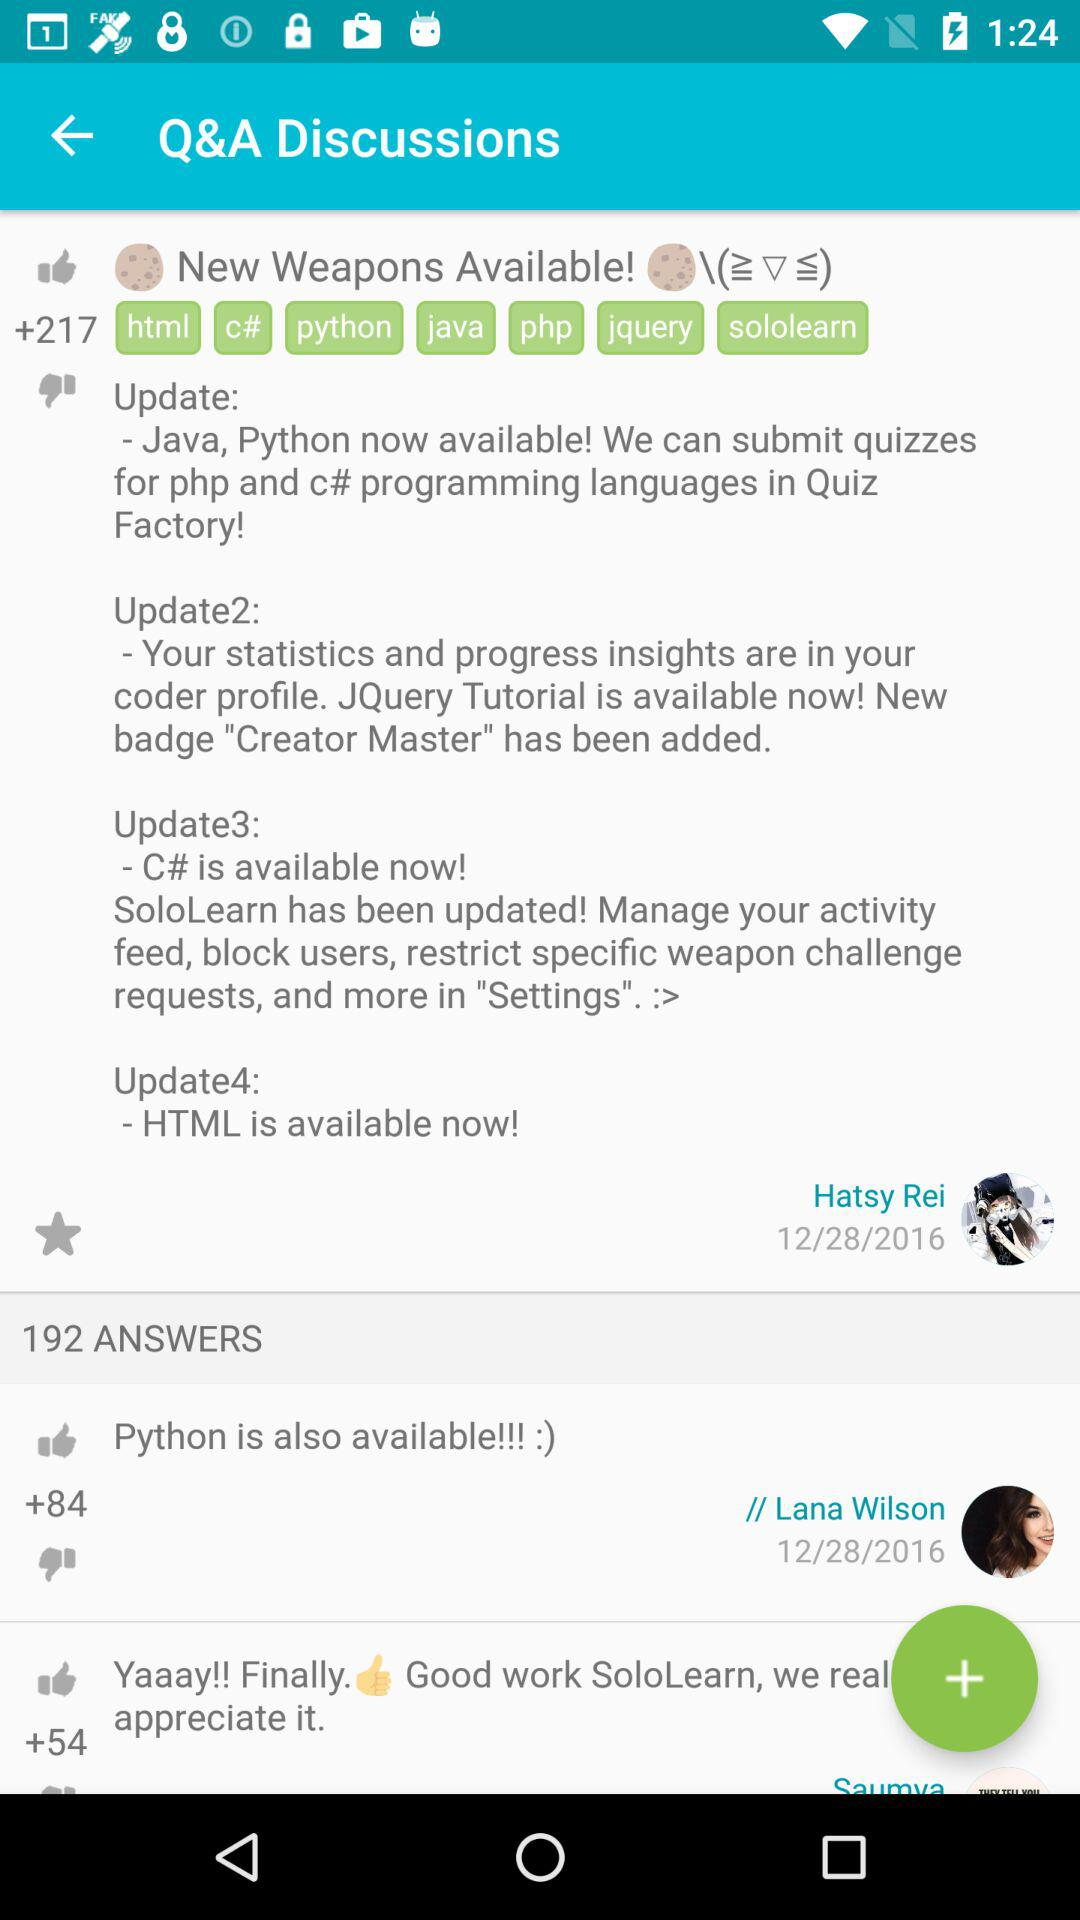What is the number of likes of Lana Wilson post? The number of likes of Lana Wilson post is 84. 